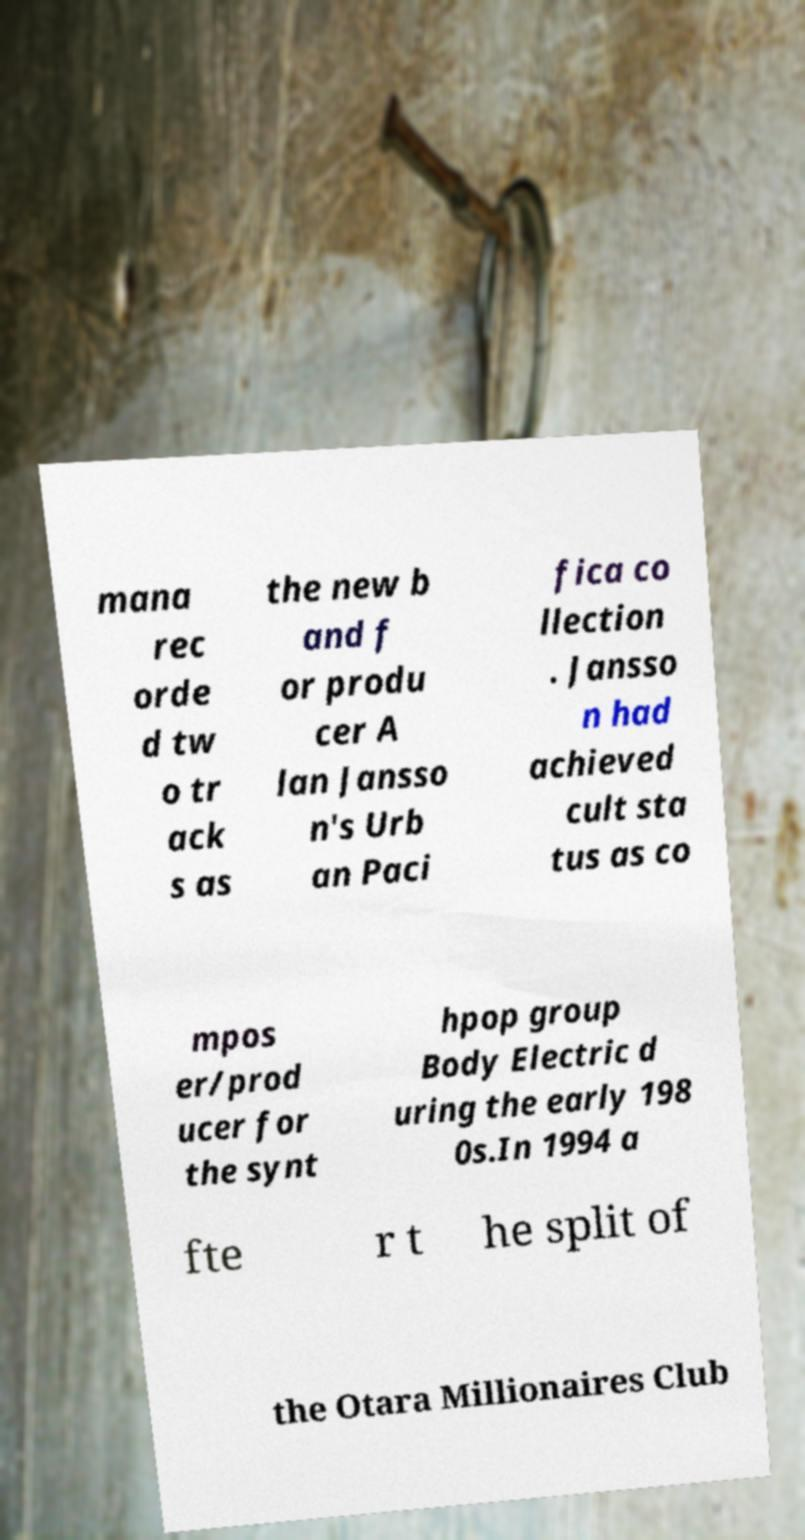Please identify and transcribe the text found in this image. mana rec orde d tw o tr ack s as the new b and f or produ cer A lan Jansso n's Urb an Paci fica co llection . Jansso n had achieved cult sta tus as co mpos er/prod ucer for the synt hpop group Body Electric d uring the early 198 0s.In 1994 a fte r t he split of the Otara Millionaires Club 